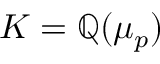Convert formula to latex. <formula><loc_0><loc_0><loc_500><loc_500>K = \mathbb { Q } ( \mu _ { p } )</formula> 